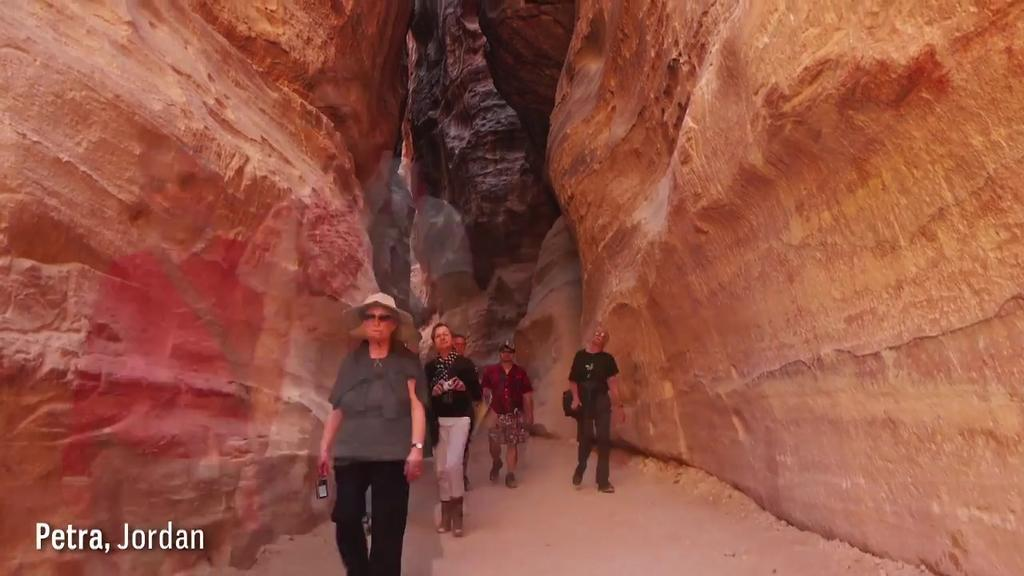What are the persons in the image doing? The persons in the image are walking. Where are the persons walking? The persons are walking on a path. What can be seen on either side of the path? There are red sandstone hills on either side of the path. What type of ornament is hanging from the boat in the image? There is no boat or ornament present in the image; it features persons walking on a path with red sandstone hills on either side. 